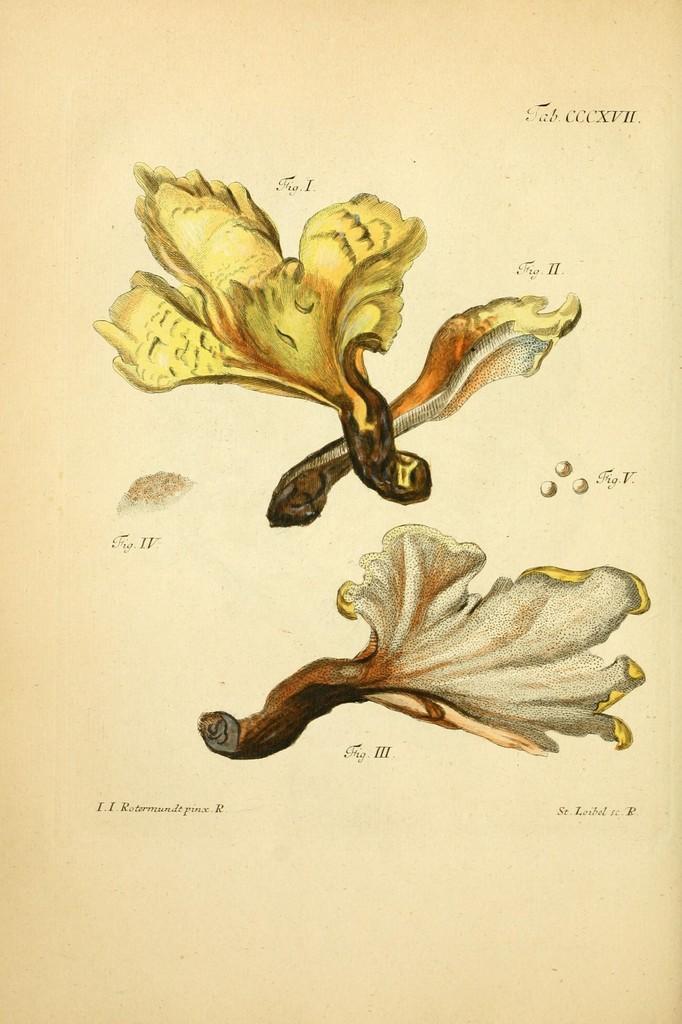Can you describe this image briefly? In this image I can see the paintings of three leaves on a white paper and also there is some text. 